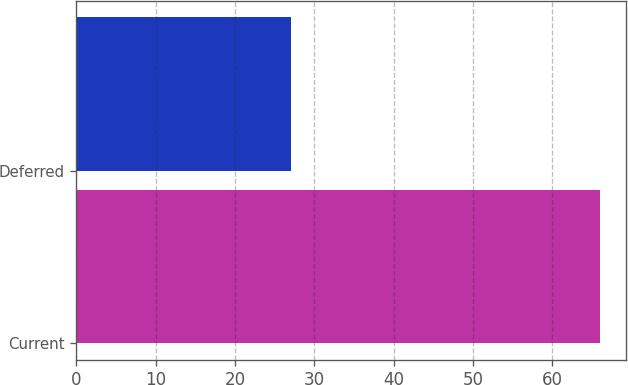<chart> <loc_0><loc_0><loc_500><loc_500><bar_chart><fcel>Current<fcel>Deferred<nl><fcel>66<fcel>27<nl></chart> 